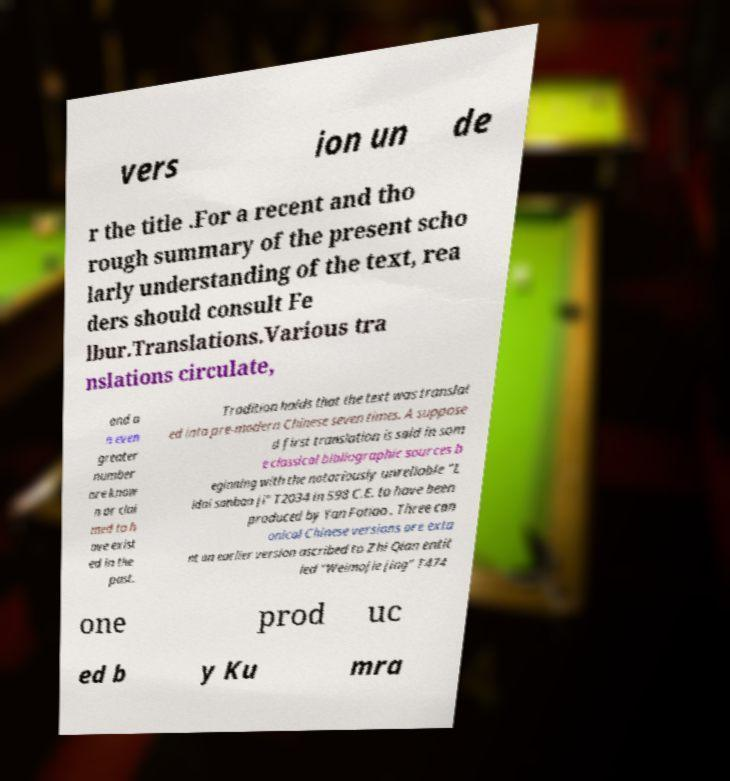There's text embedded in this image that I need extracted. Can you transcribe it verbatim? vers ion un de r the title .For a recent and tho rough summary of the present scho larly understanding of the text, rea ders should consult Fe lbur.Translations.Various tra nslations circulate, and a n even greater number are know n or clai med to h ave exist ed in the past. Tradition holds that the text was translat ed into pre-modern Chinese seven times. A suppose d first translation is said in som e classical bibliographic sources b eginning with the notoriously unreliable "L idai sanbao ji" T2034 in 598 C.E. to have been produced by Yan Fotiao . Three can onical Chinese versions are exta nt an earlier version ascribed to Zhi Qian entit led "Weimojie jing" T474 one prod uc ed b y Ku mra 